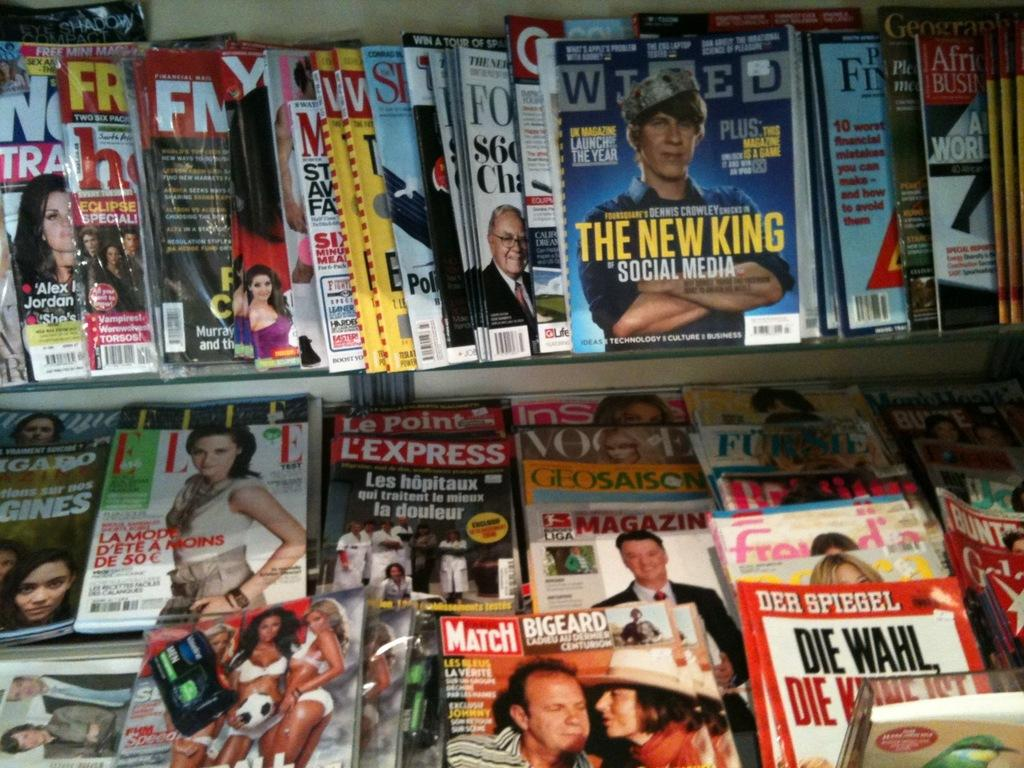<image>
Give a short and clear explanation of the subsequent image. A ton of magazines with one that says The New King 